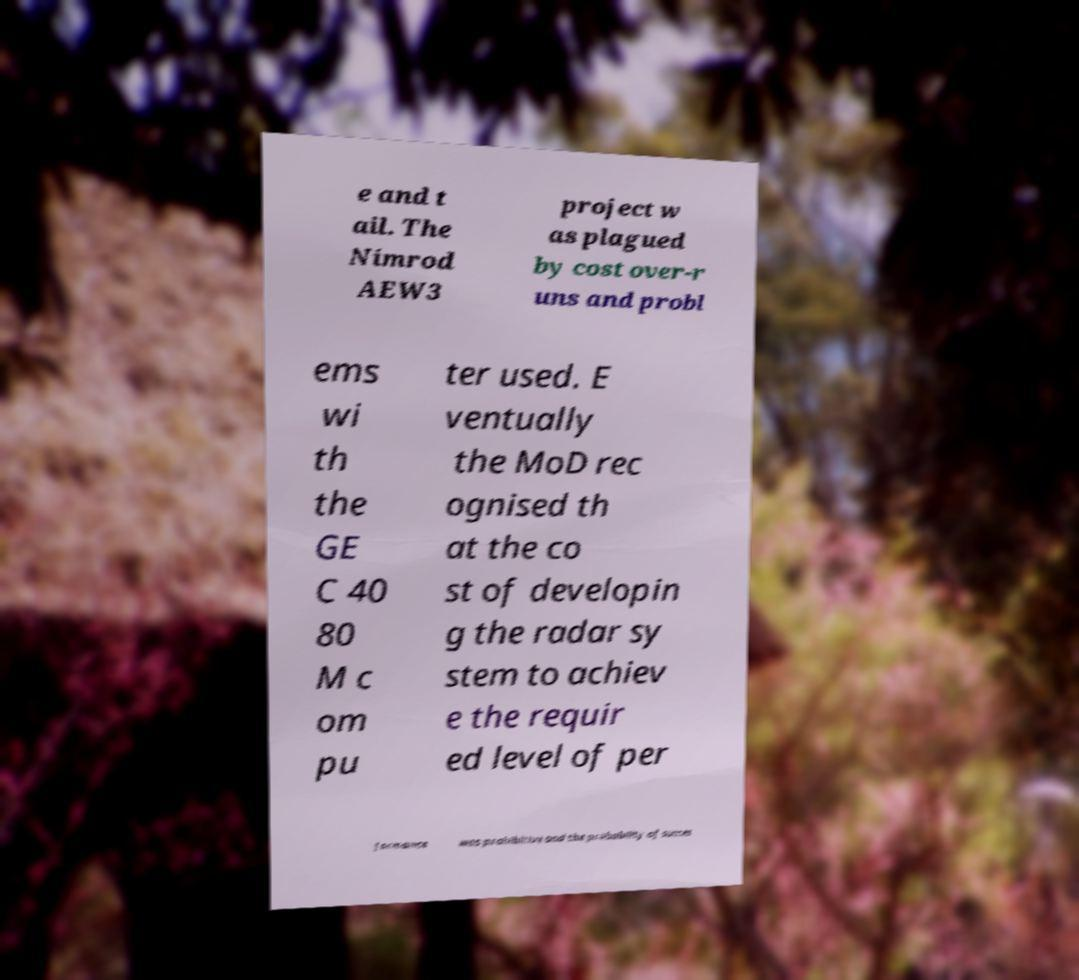What messages or text are displayed in this image? I need them in a readable, typed format. e and t ail. The Nimrod AEW3 project w as plagued by cost over-r uns and probl ems wi th the GE C 40 80 M c om pu ter used. E ventually the MoD rec ognised th at the co st of developin g the radar sy stem to achiev e the requir ed level of per formance was prohibitive and the probability of succes 